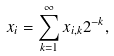Convert formula to latex. <formula><loc_0><loc_0><loc_500><loc_500>x _ { i } = \sum _ { k = 1 } ^ { \infty } x _ { i , k } 2 ^ { - k } ,</formula> 